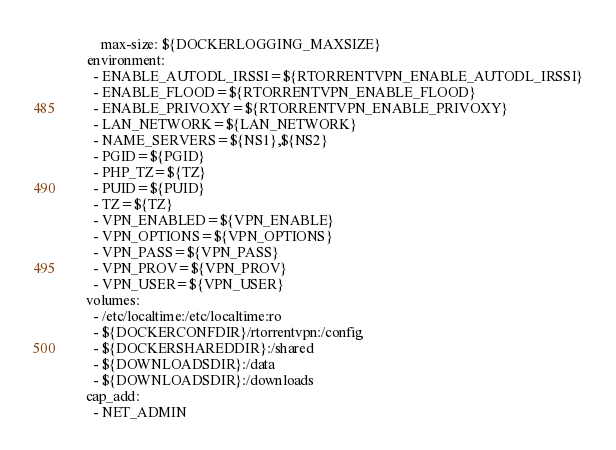<code> <loc_0><loc_0><loc_500><loc_500><_YAML_>        max-size: ${DOCKERLOGGING_MAXSIZE}
    environment:
      - ENABLE_AUTODL_IRSSI=${RTORRENTVPN_ENABLE_AUTODL_IRSSI}
      - ENABLE_FLOOD=${RTORRENTVPN_ENABLE_FLOOD}
      - ENABLE_PRIVOXY=${RTORRENTVPN_ENABLE_PRIVOXY}
      - LAN_NETWORK=${LAN_NETWORK}
      - NAME_SERVERS=${NS1},${NS2}
      - PGID=${PGID}
      - PHP_TZ=${TZ}
      - PUID=${PUID}
      - TZ=${TZ}
      - VPN_ENABLED=${VPN_ENABLE}
      - VPN_OPTIONS=${VPN_OPTIONS}
      - VPN_PASS=${VPN_PASS}
      - VPN_PROV=${VPN_PROV}
      - VPN_USER=${VPN_USER}
    volumes:
      - /etc/localtime:/etc/localtime:ro
      - ${DOCKERCONFDIR}/rtorrentvpn:/config
      - ${DOCKERSHAREDDIR}:/shared
      - ${DOWNLOADSDIR}:/data
      - ${DOWNLOADSDIR}:/downloads
    cap_add:
      - NET_ADMIN
</code> 